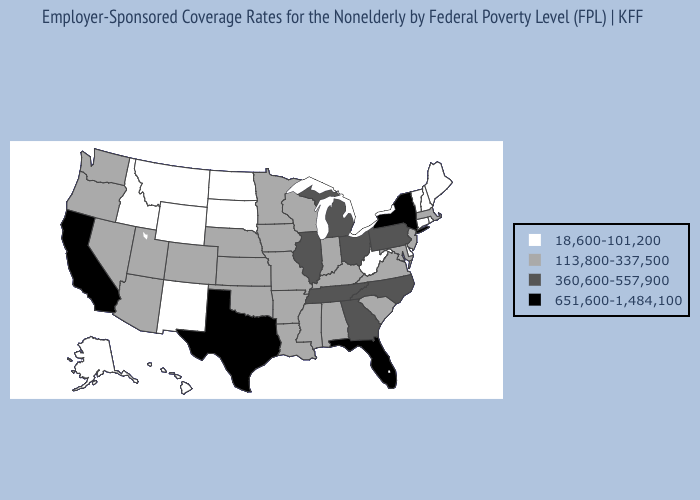Name the states that have a value in the range 360,600-557,900?
Be succinct. Georgia, Illinois, Michigan, North Carolina, Ohio, Pennsylvania, Tennessee. Does Michigan have a lower value than Vermont?
Be succinct. No. Among the states that border Vermont , does New York have the lowest value?
Quick response, please. No. Does New Jersey have a higher value than New Hampshire?
Be succinct. Yes. What is the value of Georgia?
Keep it brief. 360,600-557,900. Name the states that have a value in the range 18,600-101,200?
Short answer required. Alaska, Connecticut, Delaware, Hawaii, Idaho, Maine, Montana, New Hampshire, New Mexico, North Dakota, Rhode Island, South Dakota, Vermont, West Virginia, Wyoming. Does South Dakota have the lowest value in the USA?
Keep it brief. Yes. What is the highest value in the USA?
Short answer required. 651,600-1,484,100. Which states have the lowest value in the West?
Give a very brief answer. Alaska, Hawaii, Idaho, Montana, New Mexico, Wyoming. What is the lowest value in states that border Kentucky?
Short answer required. 18,600-101,200. What is the lowest value in the Northeast?
Quick response, please. 18,600-101,200. Does New Mexico have the same value as Utah?
Keep it brief. No. Name the states that have a value in the range 360,600-557,900?
Be succinct. Georgia, Illinois, Michigan, North Carolina, Ohio, Pennsylvania, Tennessee. Which states have the lowest value in the USA?
Give a very brief answer. Alaska, Connecticut, Delaware, Hawaii, Idaho, Maine, Montana, New Hampshire, New Mexico, North Dakota, Rhode Island, South Dakota, Vermont, West Virginia, Wyoming. 